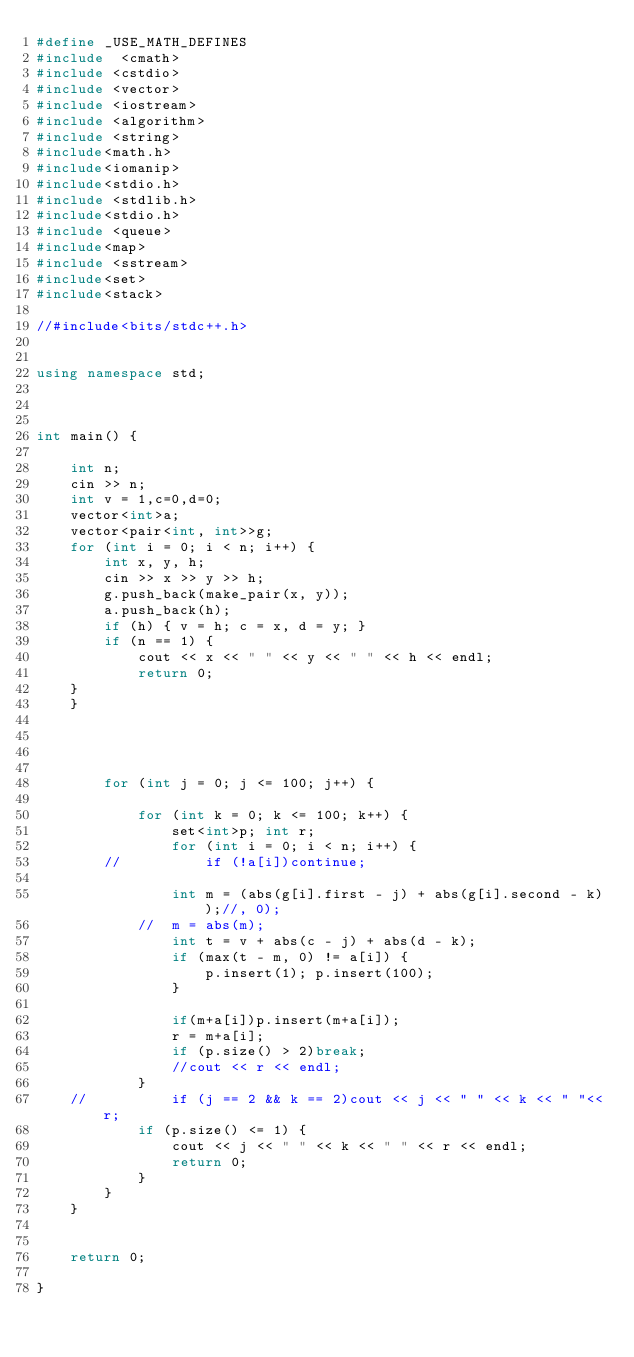Convert code to text. <code><loc_0><loc_0><loc_500><loc_500><_C++_>#define _USE_MATH_DEFINES
#include  <cmath>
#include <cstdio>
#include <vector>
#include <iostream>
#include <algorithm>
#include <string>
#include<math.h>
#include<iomanip>
#include<stdio.h>
#include <stdlib.h>
#include<stdio.h>
#include <queue>
#include<map>
#include <sstream>
#include<set>
#include<stack>

//#include<bits/stdc++.h>


using namespace std;



int main() {
	
	int n;
	cin >> n;
	int v = 1,c=0,d=0;
	vector<int>a;
	vector<pair<int, int>>g;
	for (int i = 0; i < n; i++) {
		int x, y, h;
		cin >> x >> y >> h;
		g.push_back(make_pair(x, y));
		a.push_back(h);
		if (h) { v = h; c = x, d = y; }
		if (n == 1) {
			cout << x << " " << y << " " << h << endl;
			return 0;
	}
	}
	

	
		
		for (int j = 0; j <= 100; j++) {
			
			for (int k = 0; k <= 100; k++) {
				set<int>p; int r;
				for (int i = 0; i < n; i++) {
		//			if (!a[i])continue;
					
				int m = (abs(g[i].first - j) + abs(g[i].second - k));//, 0);
			//	m = abs(m);
				int t = v + abs(c - j) + abs(d - k);
				if (max(t - m, 0) != a[i]) {
					p.insert(1); p.insert(100);
				}
				
				if(m+a[i])p.insert(m+a[i]);
				r = m+a[i];
				if (p.size() > 2)break;
				//cout << r << endl;
			}
	//			if (j == 2 && k == 2)cout << j << " " << k << " "<<r;
			if (p.size() <= 1) {
				cout << j << " " << k << " " << r << endl;
				return 0;
			}
		}
	}


	return 0;

}</code> 